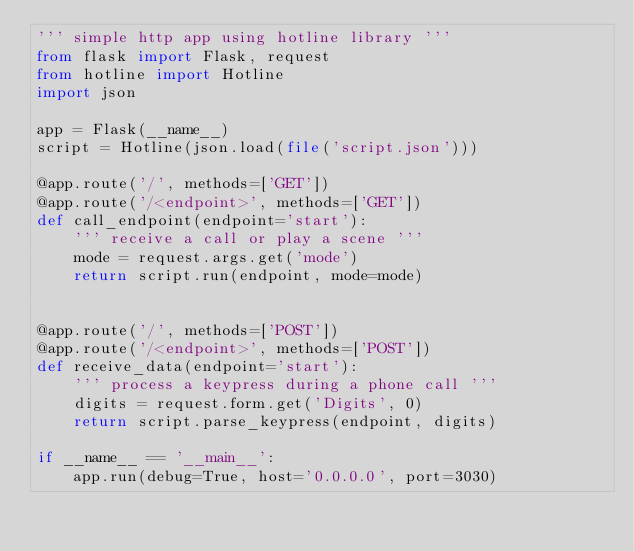<code> <loc_0><loc_0><loc_500><loc_500><_Python_>''' simple http app using hotline library '''
from flask import Flask, request
from hotline import Hotline
import json

app = Flask(__name__)
script = Hotline(json.load(file('script.json')))

@app.route('/', methods=['GET'])
@app.route('/<endpoint>', methods=['GET'])
def call_endpoint(endpoint='start'):
    ''' receive a call or play a scene '''
    mode = request.args.get('mode')
    return script.run(endpoint, mode=mode)


@app.route('/', methods=['POST'])
@app.route('/<endpoint>', methods=['POST'])
def receive_data(endpoint='start'):
    ''' process a keypress during a phone call '''
    digits = request.form.get('Digits', 0)
    return script.parse_keypress(endpoint, digits)

if __name__ == '__main__':
    app.run(debug=True, host='0.0.0.0', port=3030)
</code> 